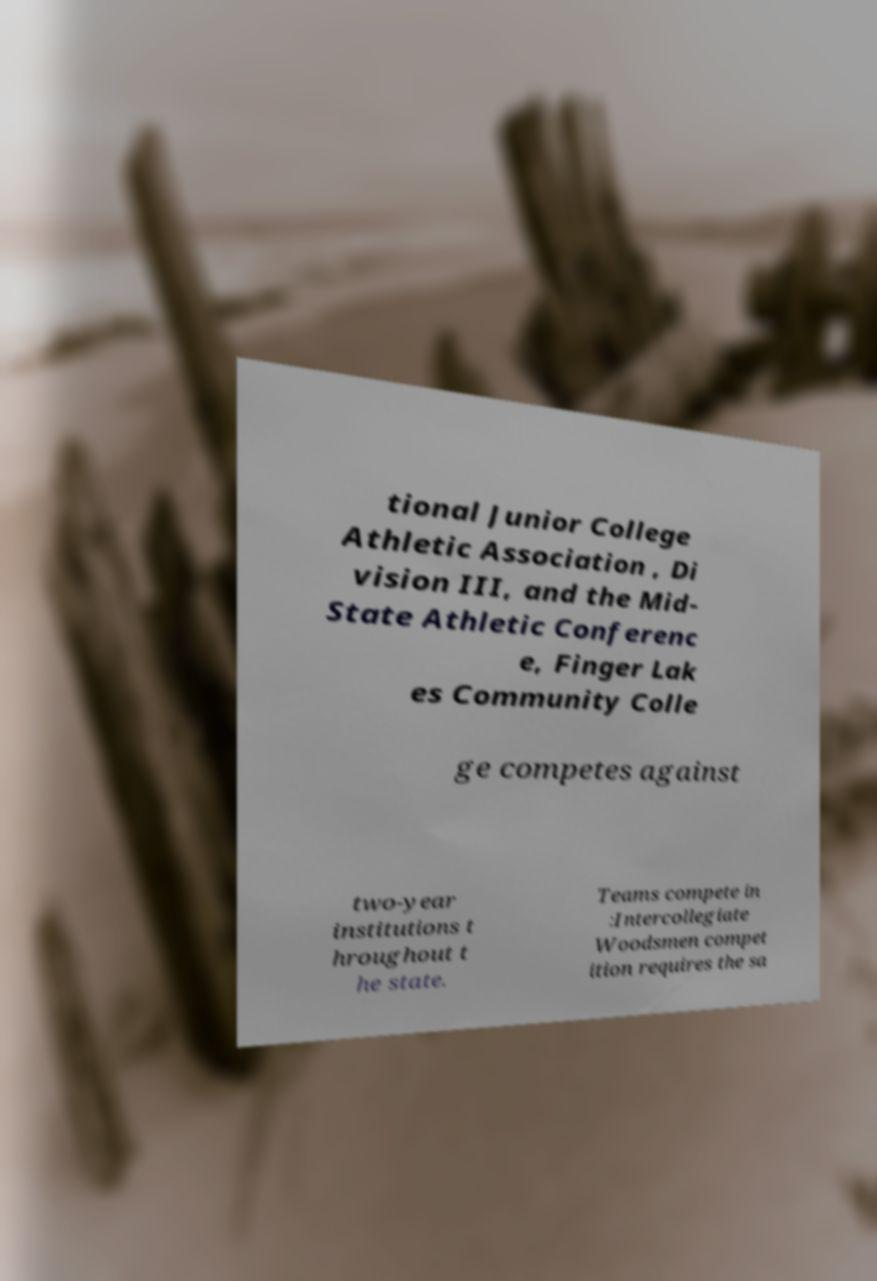Please read and relay the text visible in this image. What does it say? tional Junior College Athletic Association , Di vision III, and the Mid- State Athletic Conferenc e, Finger Lak es Community Colle ge competes against two-year institutions t hroughout t he state. Teams compete in :Intercollegiate Woodsmen compet ition requires the sa 